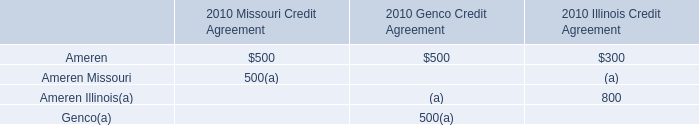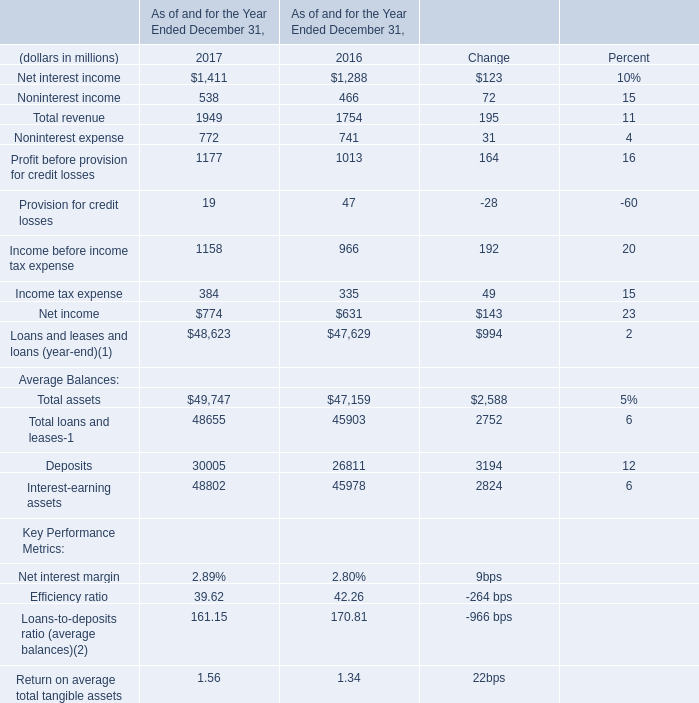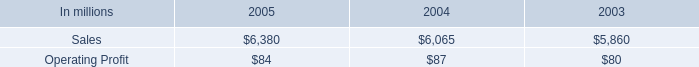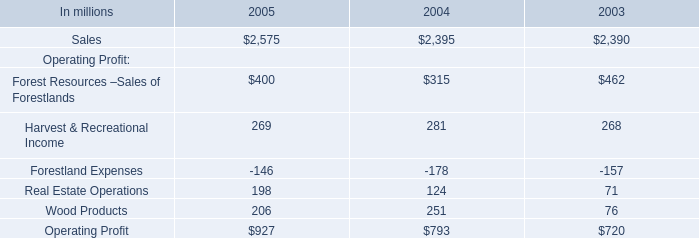If Total revenue develops with the same increasing rate in 2017, what will it reach in 2018? (in million) 
Computations: (1949 * (1 + ((1949 - 1754) / 1754)))
Answer: 2165.67902. 